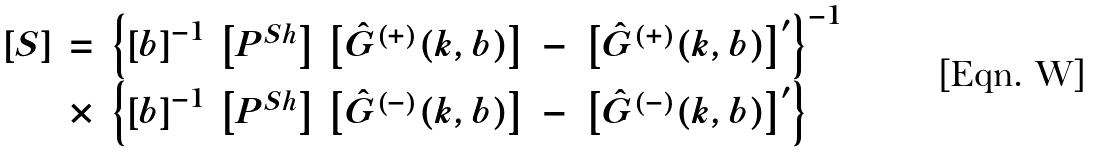Convert formula to latex. <formula><loc_0><loc_0><loc_500><loc_500>\begin{array} { c c l } \left [ S \right ] & = & \left \{ \left [ b \right ] ^ { - 1 } \, \left [ P ^ { S h } \right ] \, \left [ \hat { G } ^ { ( + ) } ( k , b ) \right ] \ - \ \left [ \hat { G } ^ { ( + ) } ( k , b ) \right ] ^ { \prime } \right \} ^ { - 1 } \\ & \times & \left \{ \left [ b \right ] ^ { - 1 } \, \left [ P ^ { S h } \right ] \, \left [ \hat { G } ^ { ( - ) } ( k , b ) \right ] \ - \ \left [ \hat { G } ^ { ( - ) } ( k , b ) \right ] ^ { \prime } \right \} \end{array}</formula> 